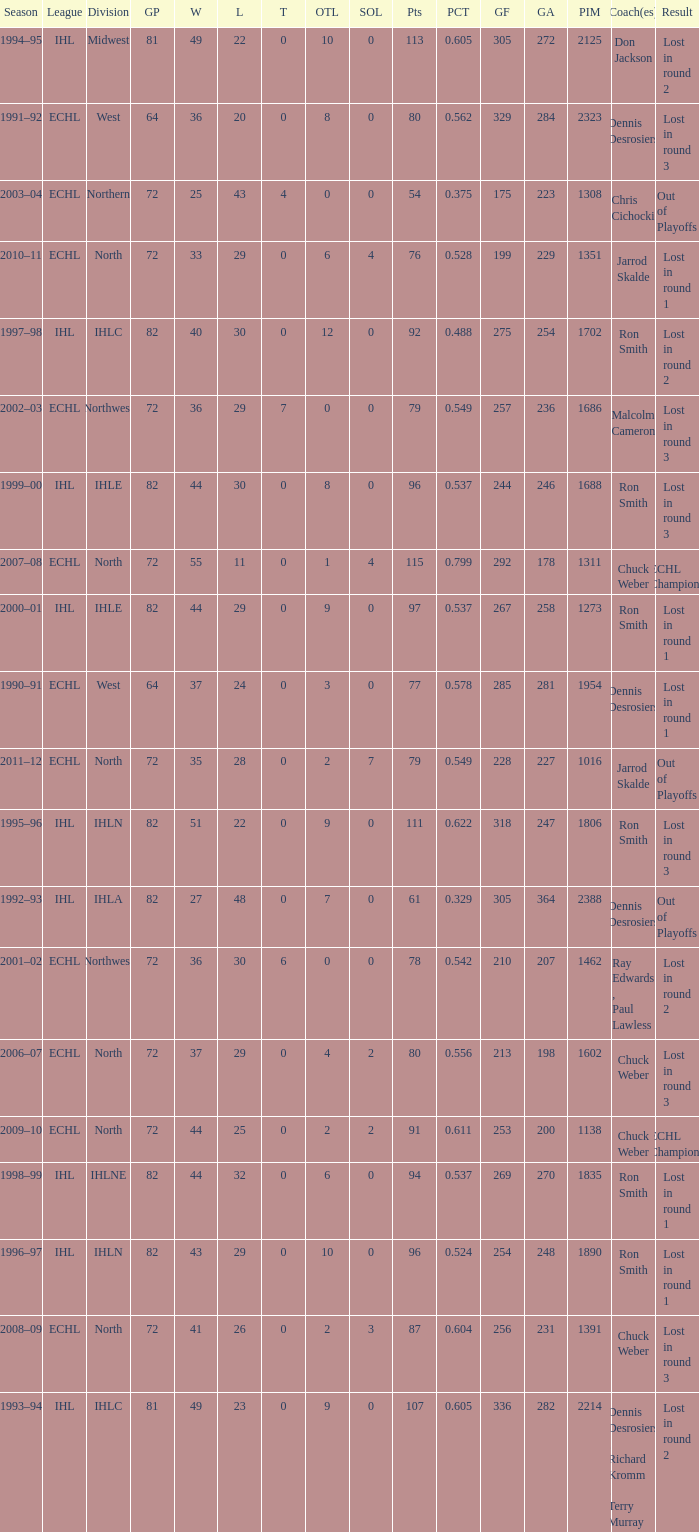What was the highest SOL where the team lost in round 3? 3.0. 